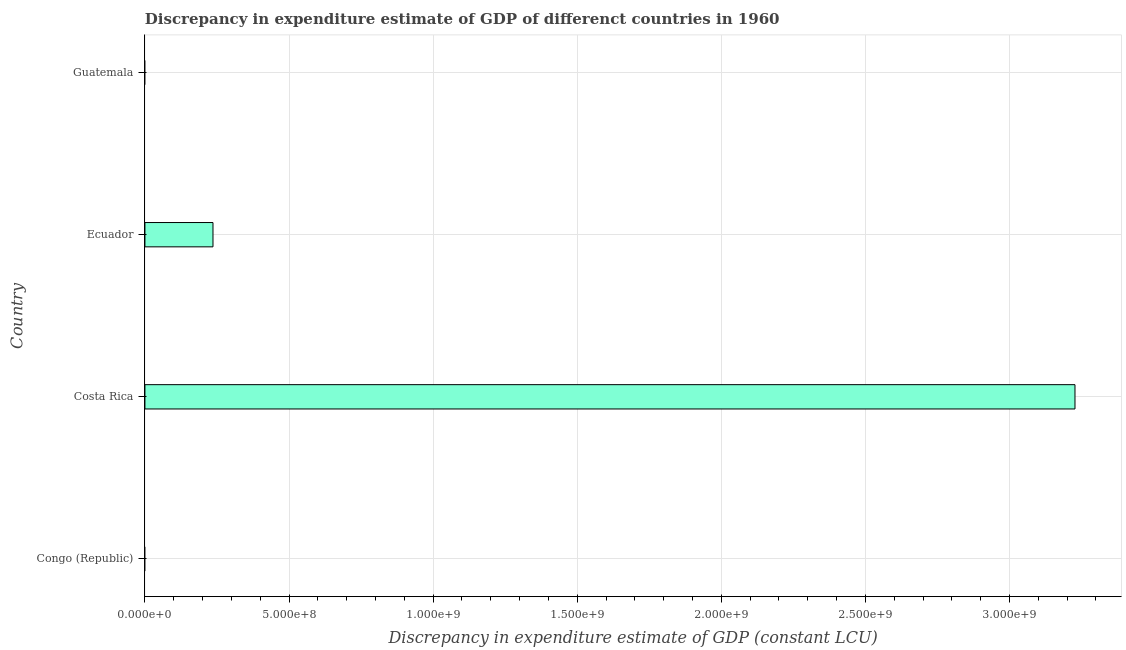What is the title of the graph?
Ensure brevity in your answer.  Discrepancy in expenditure estimate of GDP of differenct countries in 1960. What is the label or title of the X-axis?
Ensure brevity in your answer.  Discrepancy in expenditure estimate of GDP (constant LCU). What is the discrepancy in expenditure estimate of gdp in Ecuador?
Your response must be concise. 2.36e+08. Across all countries, what is the maximum discrepancy in expenditure estimate of gdp?
Your answer should be very brief. 3.23e+09. In which country was the discrepancy in expenditure estimate of gdp maximum?
Make the answer very short. Costa Rica. What is the sum of the discrepancy in expenditure estimate of gdp?
Ensure brevity in your answer.  3.46e+09. What is the difference between the discrepancy in expenditure estimate of gdp in Costa Rica and Ecuador?
Give a very brief answer. 2.99e+09. What is the average discrepancy in expenditure estimate of gdp per country?
Your answer should be compact. 8.66e+08. What is the median discrepancy in expenditure estimate of gdp?
Your answer should be very brief. 1.18e+08. What is the ratio of the discrepancy in expenditure estimate of gdp in Costa Rica to that in Ecuador?
Your response must be concise. 13.66. Is the discrepancy in expenditure estimate of gdp in Costa Rica less than that in Ecuador?
Give a very brief answer. No. Is the sum of the discrepancy in expenditure estimate of gdp in Costa Rica and Ecuador greater than the maximum discrepancy in expenditure estimate of gdp across all countries?
Your response must be concise. Yes. What is the difference between the highest and the lowest discrepancy in expenditure estimate of gdp?
Keep it short and to the point. 3.23e+09. Are all the bars in the graph horizontal?
Offer a terse response. Yes. What is the Discrepancy in expenditure estimate of GDP (constant LCU) in Costa Rica?
Provide a short and direct response. 3.23e+09. What is the Discrepancy in expenditure estimate of GDP (constant LCU) in Ecuador?
Offer a very short reply. 2.36e+08. What is the Discrepancy in expenditure estimate of GDP (constant LCU) of Guatemala?
Offer a terse response. 0. What is the difference between the Discrepancy in expenditure estimate of GDP (constant LCU) in Costa Rica and Ecuador?
Ensure brevity in your answer.  2.99e+09. What is the ratio of the Discrepancy in expenditure estimate of GDP (constant LCU) in Costa Rica to that in Ecuador?
Your answer should be compact. 13.66. 